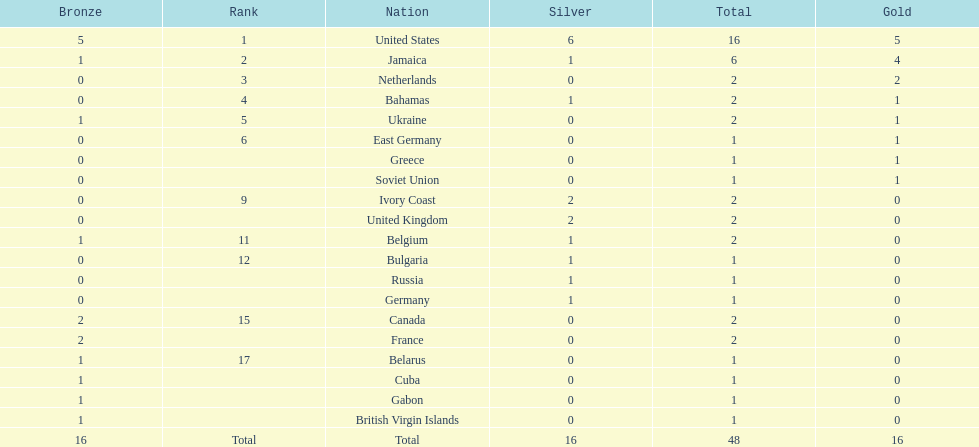In how many countries have more than one silver medal been won? 3. 